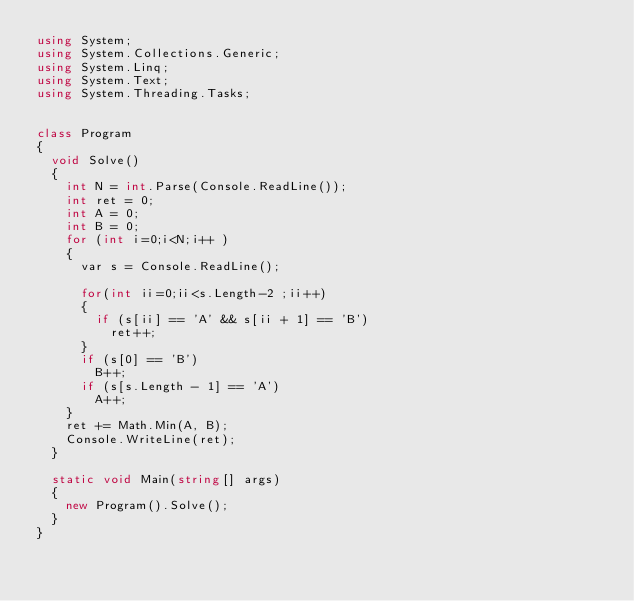Convert code to text. <code><loc_0><loc_0><loc_500><loc_500><_C#_>using System;
using System.Collections.Generic;
using System.Linq;
using System.Text;
using System.Threading.Tasks;


class Program
{
  void Solve()
  {
    int N = int.Parse(Console.ReadLine());
    int ret = 0;
    int A = 0;
    int B = 0;
    for (int i=0;i<N;i++ )
    {
      var s = Console.ReadLine();

      for(int ii=0;ii<s.Length-2 ;ii++)
      {
        if (s[ii] == 'A' && s[ii + 1] == 'B')
          ret++;
      }
      if (s[0] == 'B')
        B++;
      if (s[s.Length - 1] == 'A')
        A++;
    }
    ret += Math.Min(A, B);
    Console.WriteLine(ret);
  }

  static void Main(string[] args)
  {
    new Program().Solve();
  }
}

</code> 